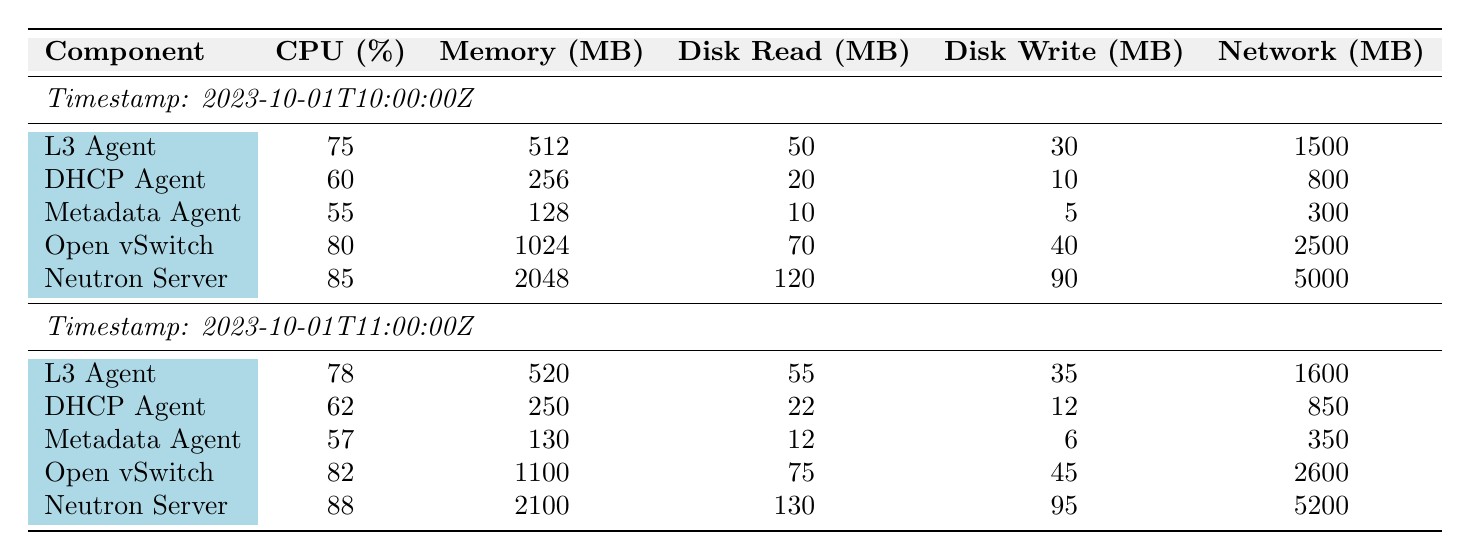What is the CPU percentage of the Neutron Server at 10:00 AM? From the table, the CPU percentage for the Neutron Server at the timestamp 2023-10-01T10:00:00Z is directly listed as 85%.
Answer: 85% What was the memory usage of the Open vSwitch at 11:00 AM? The memory usage for the Open vSwitch at 2023-10-01T11:00:00Z is stated in the table as 1100 MB.
Answer: 1100 MB Which component had the lowest CPU percentage at 10:00 AM? At 10:00 AM, the CPU percentages for all components are: L3 Agent (75%), DHCP Agent (60%), Metadata Agent (55%), Open vSwitch (80%), and Neutron Server (85%). The lowest among these is the Metadata Agent with 55%.
Answer: Metadata Agent What is the total disk write value for all components at 11:00 AM? The disk write values at 11:00 AM are: L3 Agent (35 MB), DHCP Agent (12 MB), Metadata Agent (6 MB), Open vSwitch (45 MB), and Neutron Server (95 MB). Summing these gives: 35 + 12 + 6 + 45 + 95 = 193 MB.
Answer: 193 MB Is the network traffic of the DHCP Agent higher at 10:00 AM than at 11:00 AM? At 10:00 AM, the network traffic of the DHCP Agent is 800 MB, and at 11:00 AM, it is 850 MB. Since 800 MB is less than 850 MB, the statement is false.
Answer: No What is the average memory usage of all the components at 10:00 AM? The memory usages at 10:00 AM are: L3 Agent (512 MB), DHCP Agent (256 MB), Metadata Agent (128 MB), Open vSwitch (1024 MB), and Neutron Server (2048 MB). To find the average, sum them: 512 + 256 + 128 + 1024 + 2048 = 3968 MB, and divide by 5: 3968/5 = 793.6 MB.
Answer: 793.6 MB Which component has the highest network traffic across both timestamps? Looking at the network traffic values: At 10:00 AM, Neutron Server had 5000 MB, and at 11:00 AM it had 5200 MB. The Open vSwitch had 2500 MB at 10:00 AM and 2600 MB at 11:00 AM. Thus, the Neutron Server has the highest network traffic at 5200 MB, which occurs at 11:00 AM.
Answer: Neutron Server Was the CPU utilization of the L3 Agent higher at 11:00 AM compared to 10:00 AM? The L3 Agent had a CPU percentage of 75% at 10:00 AM and 78% at 11:00 AM. Since 78% is greater than 75%, the answer is yes.
Answer: Yes 